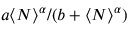Convert formula to latex. <formula><loc_0><loc_0><loc_500><loc_500>a \langle N \rangle ^ { \alpha } / ( b + \langle N \rangle ^ { \alpha } )</formula> 